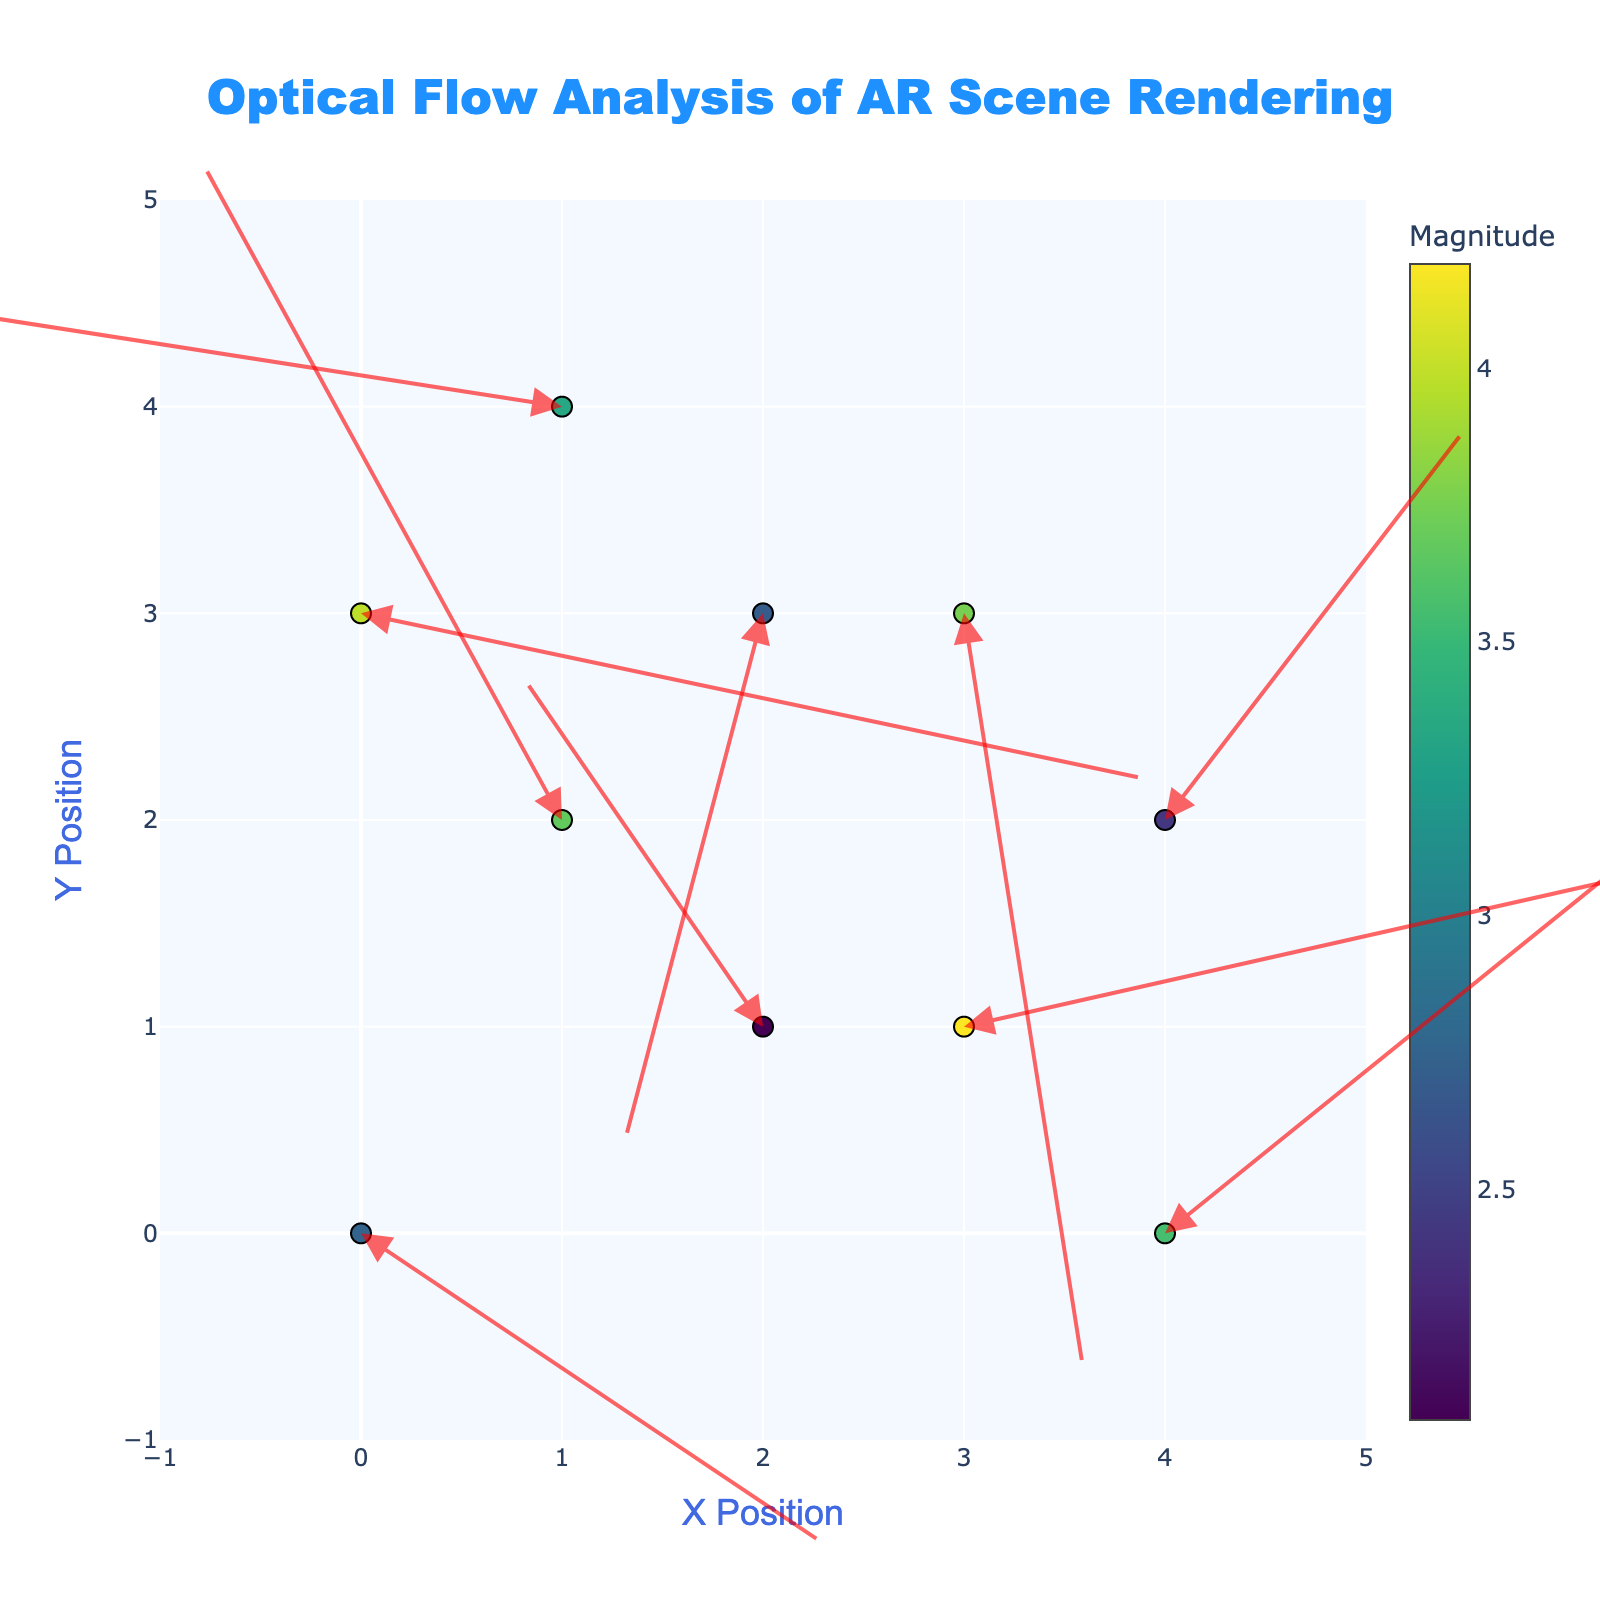What is the title of the figure? The title is displayed at the top of the chart. It specifies the visualization focus is on optical flow analysis in AR scene rendering.
Answer: Optical Flow Analysis of AR Scene Rendering What are the ranges of the X and Y axes? The X and Y axes range from -1 to 5, as indicated by the axis limits.
Answer: -1 to 5 How many data points are shown in the figure? Counting all the individual data points/markers, which are the origins of the arrows (quivers), gives us the total number of data points.
Answer: 10 Which data point has the highest optical flow magnitude, and what is that magnitude? By observing the color scale (where darker colors indicate higher magnitudes) and matching it with the 'Magnitude' values from the dataset, you find the highest value.
Answer: Point at (3,3) with 3.75 Identify the direction for the data point located at (0, 0). The direction is shown in the hover text when you hover over the point. The text displays Direction as degrees.
Answer: 326.8° What is the average magnitude of all data points? Add up all 'Magnitude' values: 2.75 + 3.67 + 4.19 + 2.69 + 2.43 + 3.34 + 3.75 + 3.56 + 2.08 + 3.98 = 32.44. Then, divide by the number of data points (10).
Answer: 3.244 Compare the arrows at positions (1, 2) and (2, 3). Which one has a greater magnitude? Check the 'Magnitude' value for both points: (1, 2) has 3.67, (2, 3) has 2.69. Thus, (1, 2) has a greater magnitude.
Answer: (1, 2) What is the average degree direction of the arrows? Sum all 'Direction' values and divide by 10. 326.8 + 119.4 + 12.4 + 254.9 + 51.7 + 171.4 + 279.2 + 38.1 + 125.2 + 348.4 = 1727.5 degrees, then 1727.5 ÷ 10.
Answer: 172.8° Which arrow has the smallest direction (degree)? Identify the smallest 'Direction' value in the dataset, which is the arrow at (3, 1) with direction 12.4°.
Answer: Arrow at (3, 1) with 12.4° What's the sum of all U-component values? Add up all 'U' values from the dataset. 2.3 - 1.8 + 4.1 - 0.7 + 1.5 - 3.3 + 0.6 + 2.8 - 1.2 + 3.9 = 8.2
Answer: 8.2 